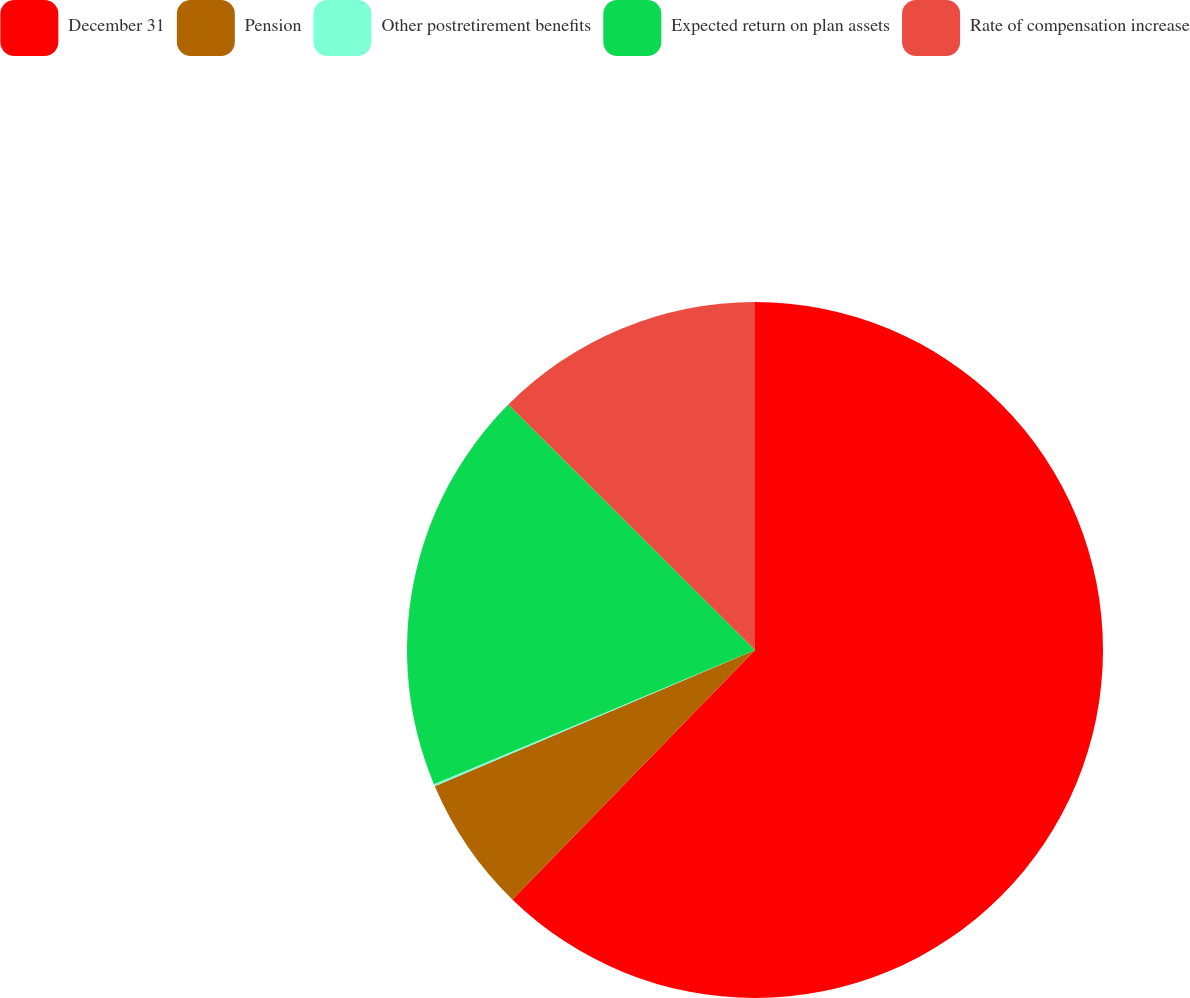Convert chart to OTSL. <chart><loc_0><loc_0><loc_500><loc_500><pie_chart><fcel>December 31<fcel>Pension<fcel>Other postretirement benefits<fcel>Expected return on plan assets<fcel>Rate of compensation increase<nl><fcel>62.28%<fcel>6.32%<fcel>0.1%<fcel>18.76%<fcel>12.54%<nl></chart> 